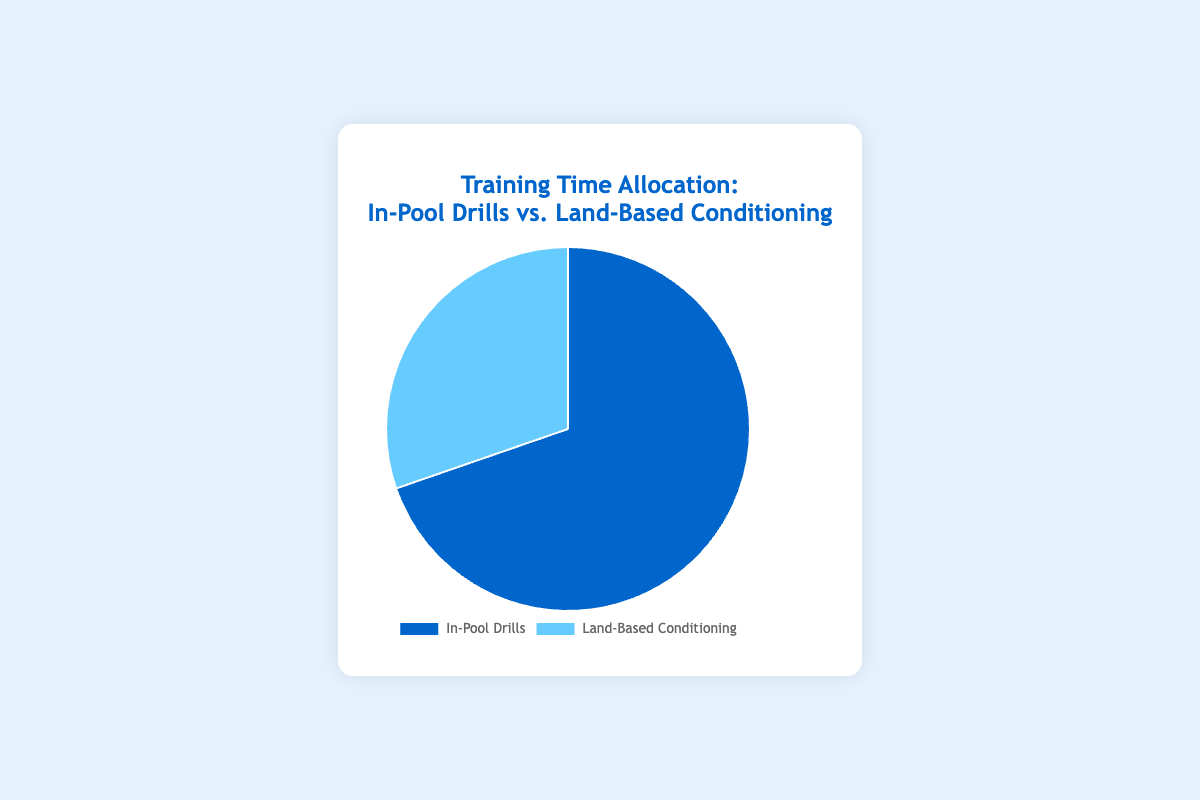What percentage of the total training time is allocated to In-Pool Drills? To find the percentage of training time allocated to In-Pool Drills, we sum the total training times for both categories, which is 460 (In-Pool) + 200 (Land-Based) = 660 minutes. Then, we calculate the percentage as (460 / 660) * 100.
Answer: 69.7% How much more time is spent on In-Pool Drills compared to Land-Based Conditioning? To find the difference, subtract the total time for Land-Based Conditioning from the total time for In-Pool Drills: 460 - 200.
Answer: 260 minutes What is the combined training time for Freestyle Technique Drills and Shooting Practices? To find the combined time, sum the values for Freestyle Technique Drills and Shooting Practices: 120 + 100.
Answer: 220 minutes Which category has the larger allocation of training time, and by how much? Compare the total times for In-Pool Drills (460 minutes) and Land-Based Conditioning (200 minutes). The category with the larger allocation is In-Pool Drills, and the difference is 460 - 200.
Answer: In-Pool Drills, by 260 minutes What is the percentage difference between the total training times allocated to In-Pool Drills and Land-Based Conditioning? First, find the difference in training times: 460 (In-Pool) - 200 (Land-Based). The difference is 260. Then, calculate the percentage difference relative to the total time (660 minutes): (260 / 660) * 100.
Answer: 39.4% Which color represents In-Pool Drills in the Pie chart? According to the provided data, the Pie chart uses dark blue for In-Pool Drills.
Answer: Dark blue If an additional 40 minutes were allocated to Cardiovascular Training, would the total time for Land-Based Conditioning exceed the total time for In-Pool Drills? First, add 40 minutes to the current Cardiovascular Training time (50), resulting in 90 minutes. Now, sum the new total for Land-Based Conditioning: 75 (Strength) + 90 (Cardio) + 30 (Flexibility) + 45 (Core). The new total is 240 minutes. Since 240 is still less than 460, the total for Land-Based does not exceed In-Pool.
Answer: No What is the estimated percentage of training time allocated to Land-Based Conditioning? To find the percentage, divide the total Land-Based training time by the overall total time and multiply by 100: (200 / 660) * 100.
Answer: Approximately 30.3% Which type of In-Pool Drill has the highest training time, and how much is it? Scrimmage Sessions have the highest training time among In-Pool Drills, with a total of 150 minutes.
Answer: Scrimmage Sessions, 150 minutes 